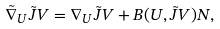Convert formula to latex. <formula><loc_0><loc_0><loc_500><loc_500>\tilde { \nabla } _ { U } \tilde { J } V = \nabla _ { U } \tilde { J } V + B ( U , \tilde { J } V ) N ,</formula> 